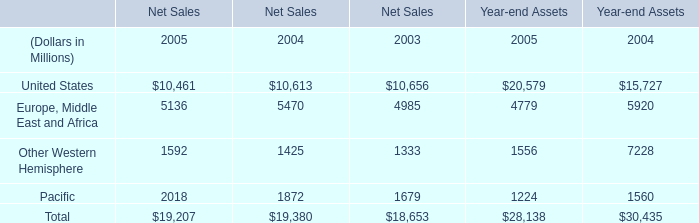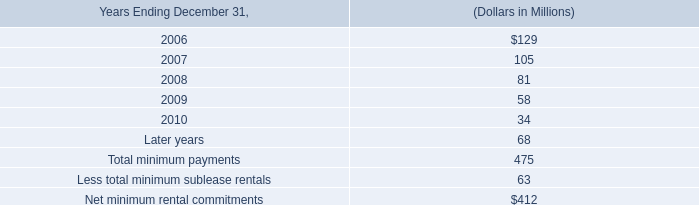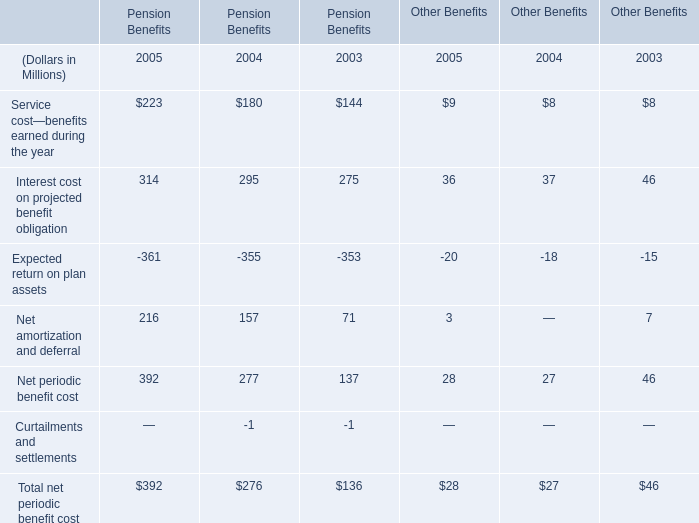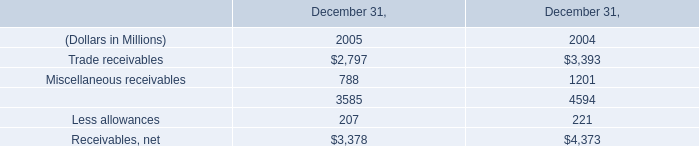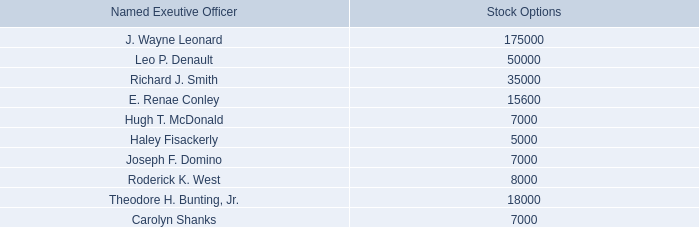Which year is Interest cost on projected benefit obligation the highest for Pension Benefits? 
Answer: 2005. 